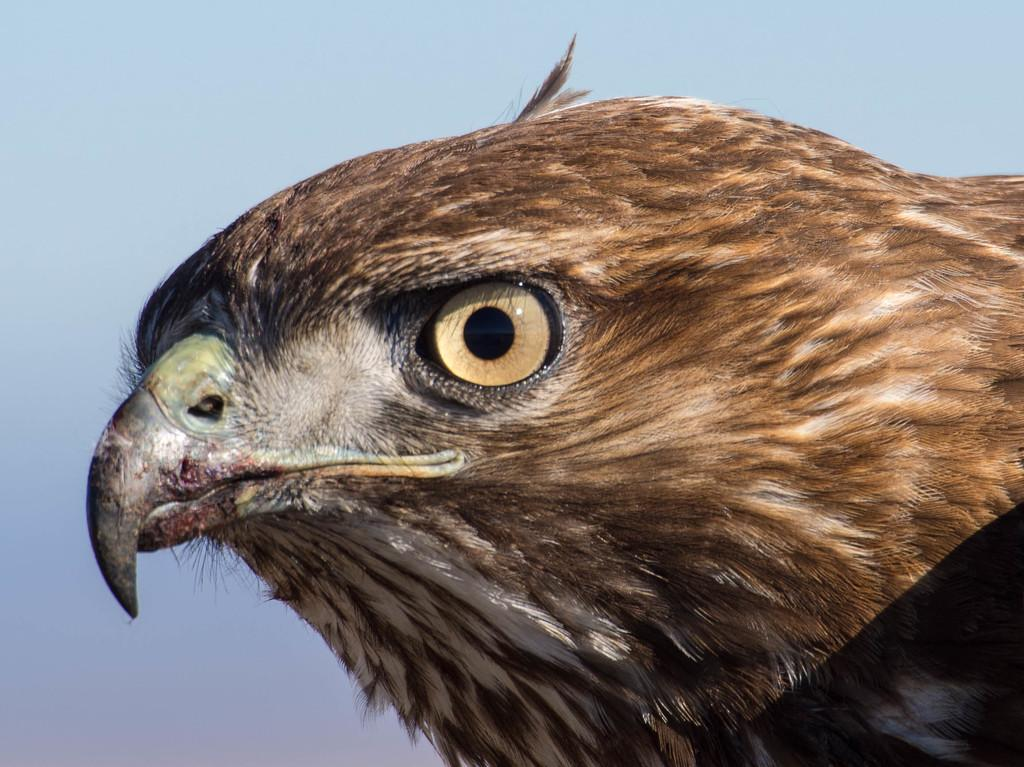What type of bird is in the image? There is an eagle in the image. What specific features of the eagle are visible? The eagle's face, beak, eye, and feathers are visible in the image. What is the color of the background in the image? The background of the image is light blue in color. What month is depicted in the image? There is no month depicted in the image; it features an eagle with a light blue background. Can you tell me how the volcano affects the acoustics in the image? There is no volcano present in the image, and therefore no impact on acoustics can be observed. 